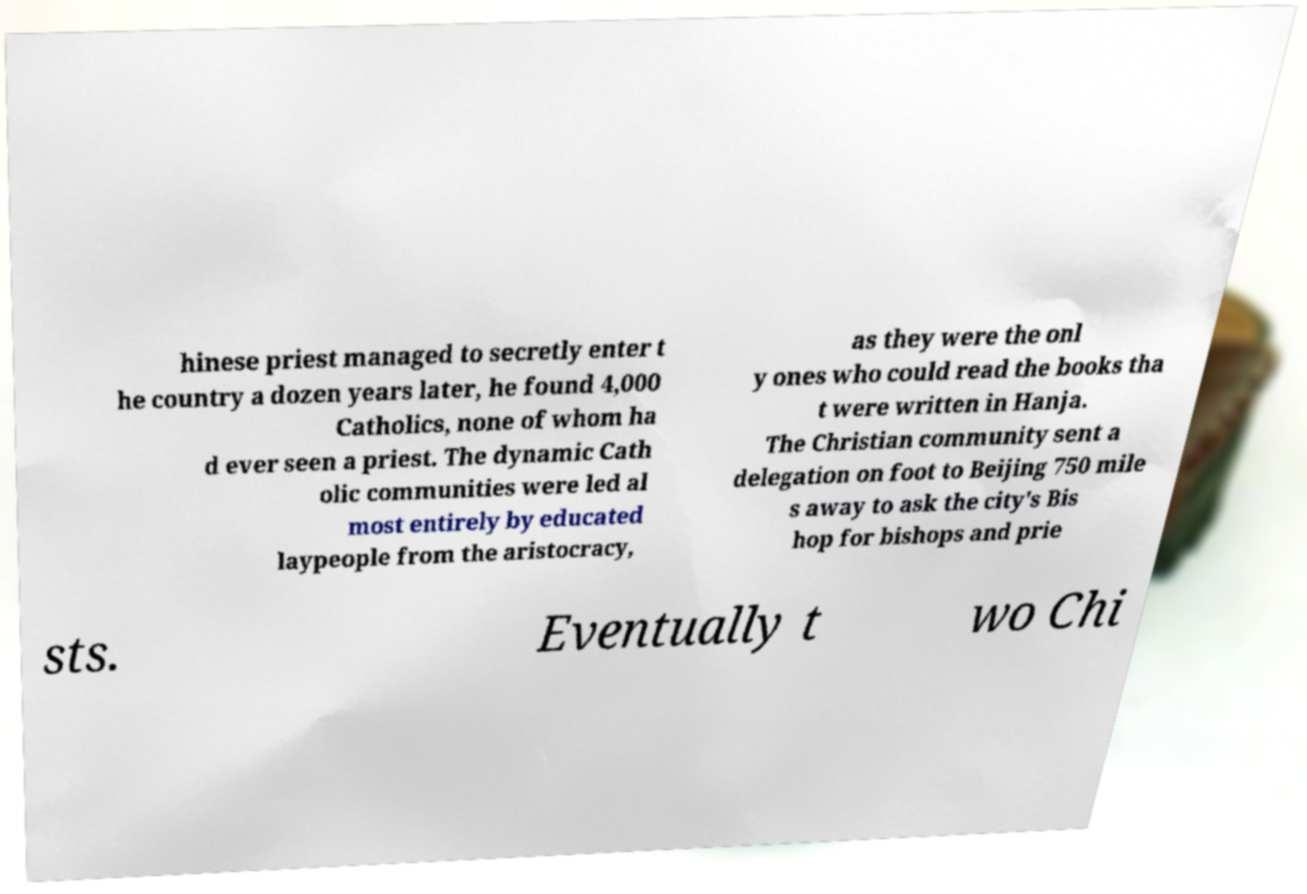Could you assist in decoding the text presented in this image and type it out clearly? hinese priest managed to secretly enter t he country a dozen years later, he found 4,000 Catholics, none of whom ha d ever seen a priest. The dynamic Cath olic communities were led al most entirely by educated laypeople from the aristocracy, as they were the onl y ones who could read the books tha t were written in Hanja. The Christian community sent a delegation on foot to Beijing 750 mile s away to ask the city's Bis hop for bishops and prie sts. Eventually t wo Chi 